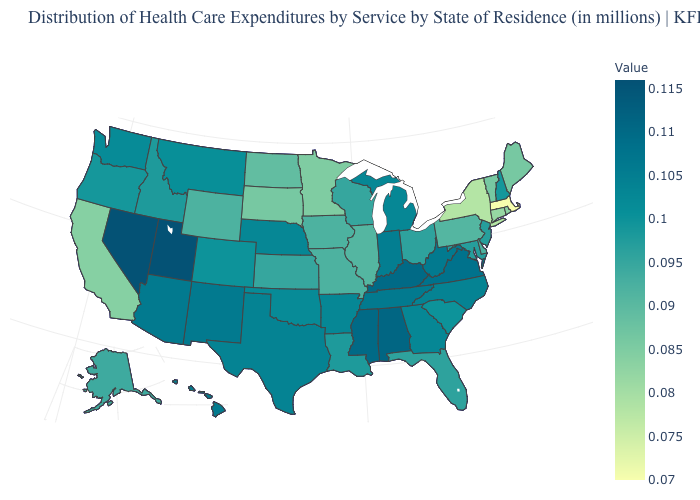Among the states that border Massachusetts , which have the highest value?
Short answer required. New Hampshire. Does South Carolina have the highest value in the South?
Concise answer only. No. Does Iowa have a lower value than Rhode Island?
Answer briefly. No. Does Arkansas have a lower value than Massachusetts?
Answer briefly. No. 